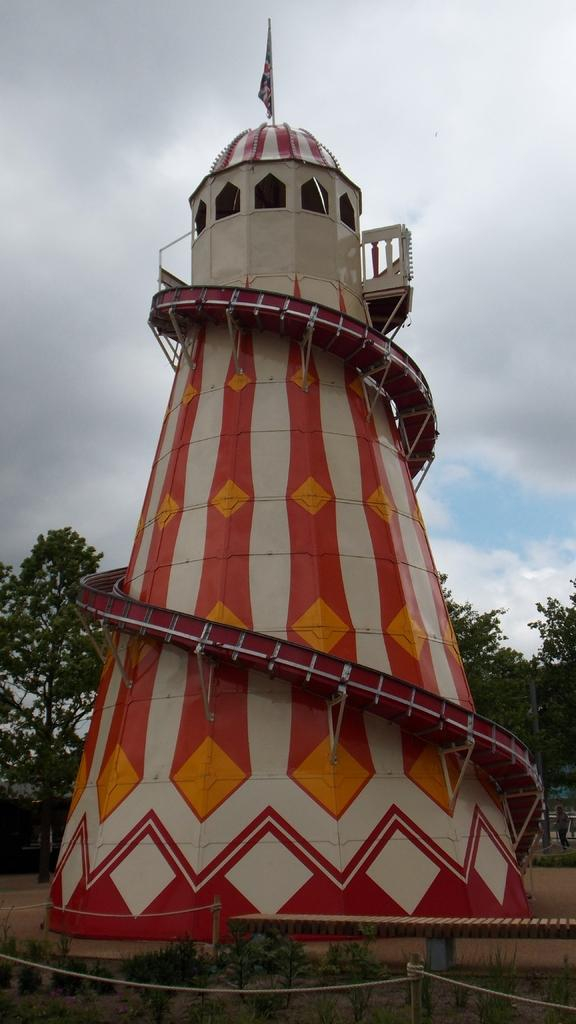What is the main structure in the image? There is a tower with a flag in the image. What can be seen in the background of the image? There are trees and plants in the background of the image. What is visible in the sky in the image? The sky is visible in the background of the image. What type of silk is draped over the tower in the image? There is no silk present in the image; it features a tower with a flag and a background of trees, plants, and the sky. 